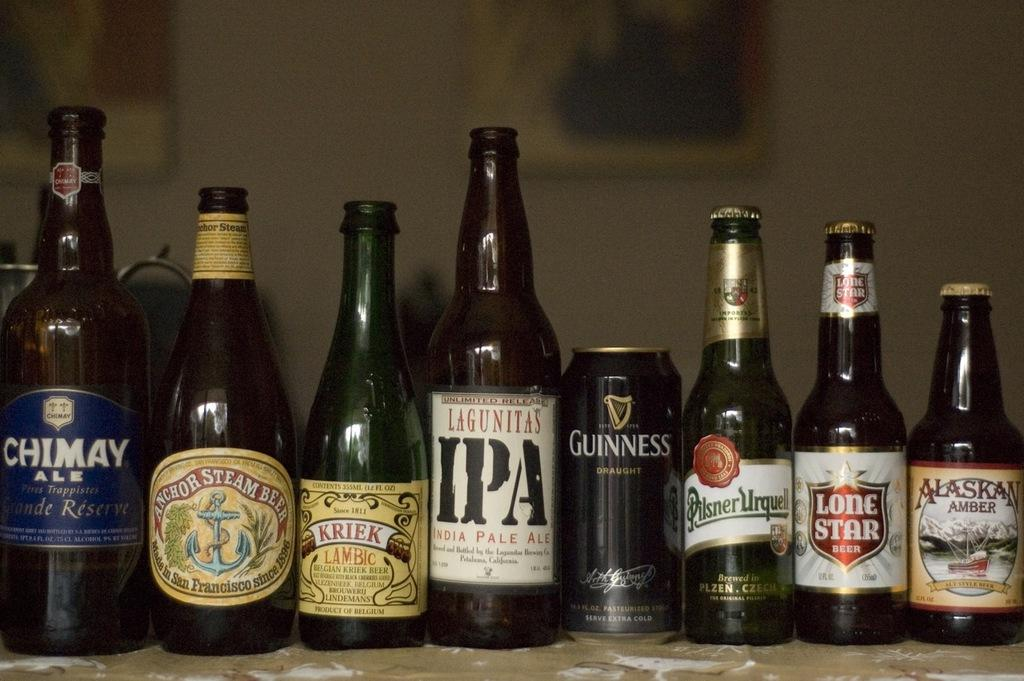<image>
Write a terse but informative summary of the picture. A number of bottles of beer and one can, including Guiness and Lone Star. 